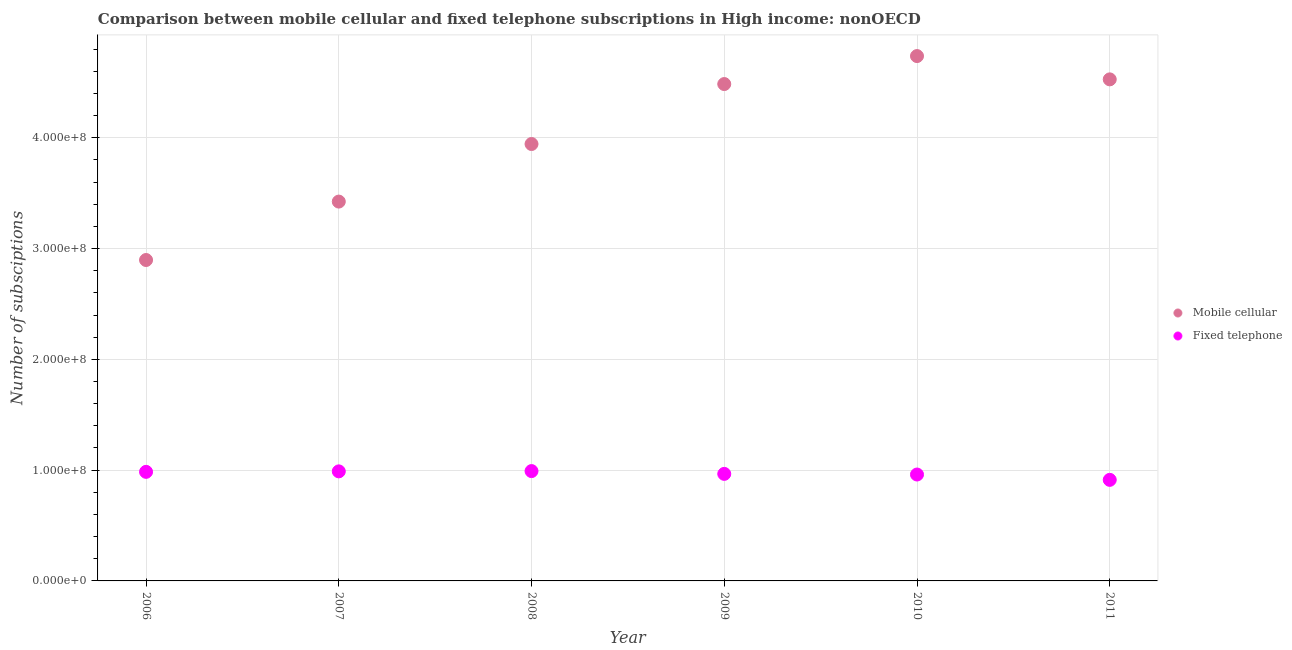How many different coloured dotlines are there?
Your answer should be compact. 2. Is the number of dotlines equal to the number of legend labels?
Keep it short and to the point. Yes. What is the number of fixed telephone subscriptions in 2009?
Your response must be concise. 9.66e+07. Across all years, what is the maximum number of fixed telephone subscriptions?
Ensure brevity in your answer.  9.91e+07. Across all years, what is the minimum number of fixed telephone subscriptions?
Make the answer very short. 9.12e+07. In which year was the number of fixed telephone subscriptions minimum?
Your answer should be very brief. 2011. What is the total number of mobile cellular subscriptions in the graph?
Your response must be concise. 2.40e+09. What is the difference between the number of mobile cellular subscriptions in 2007 and that in 2008?
Provide a short and direct response. -5.20e+07. What is the difference between the number of mobile cellular subscriptions in 2011 and the number of fixed telephone subscriptions in 2007?
Your answer should be compact. 3.54e+08. What is the average number of fixed telephone subscriptions per year?
Keep it short and to the point. 9.67e+07. In the year 2009, what is the difference between the number of fixed telephone subscriptions and number of mobile cellular subscriptions?
Keep it short and to the point. -3.52e+08. In how many years, is the number of fixed telephone subscriptions greater than 160000000?
Provide a succinct answer. 0. What is the ratio of the number of fixed telephone subscriptions in 2009 to that in 2010?
Your answer should be compact. 1.01. Is the number of mobile cellular subscriptions in 2007 less than that in 2008?
Your answer should be compact. Yes. Is the difference between the number of fixed telephone subscriptions in 2009 and 2011 greater than the difference between the number of mobile cellular subscriptions in 2009 and 2011?
Your answer should be very brief. Yes. What is the difference between the highest and the second highest number of mobile cellular subscriptions?
Give a very brief answer. 2.10e+07. What is the difference between the highest and the lowest number of mobile cellular subscriptions?
Make the answer very short. 1.84e+08. Is the sum of the number of fixed telephone subscriptions in 2008 and 2011 greater than the maximum number of mobile cellular subscriptions across all years?
Ensure brevity in your answer.  No. Does the number of mobile cellular subscriptions monotonically increase over the years?
Keep it short and to the point. No. Is the number of fixed telephone subscriptions strictly greater than the number of mobile cellular subscriptions over the years?
Your answer should be very brief. No. Are the values on the major ticks of Y-axis written in scientific E-notation?
Provide a succinct answer. Yes. Does the graph contain grids?
Offer a very short reply. Yes. Where does the legend appear in the graph?
Provide a succinct answer. Center right. How many legend labels are there?
Ensure brevity in your answer.  2. What is the title of the graph?
Your answer should be compact. Comparison between mobile cellular and fixed telephone subscriptions in High income: nonOECD. What is the label or title of the Y-axis?
Give a very brief answer. Number of subsciptions. What is the Number of subsciptions of Mobile cellular in 2006?
Your answer should be compact. 2.90e+08. What is the Number of subsciptions of Fixed telephone in 2006?
Your answer should be very brief. 9.84e+07. What is the Number of subsciptions in Mobile cellular in 2007?
Keep it short and to the point. 3.42e+08. What is the Number of subsciptions of Fixed telephone in 2007?
Offer a terse response. 9.89e+07. What is the Number of subsciptions of Mobile cellular in 2008?
Offer a terse response. 3.94e+08. What is the Number of subsciptions of Fixed telephone in 2008?
Provide a succinct answer. 9.91e+07. What is the Number of subsciptions of Mobile cellular in 2009?
Your answer should be very brief. 4.48e+08. What is the Number of subsciptions in Fixed telephone in 2009?
Offer a terse response. 9.66e+07. What is the Number of subsciptions in Mobile cellular in 2010?
Provide a short and direct response. 4.74e+08. What is the Number of subsciptions of Fixed telephone in 2010?
Offer a terse response. 9.60e+07. What is the Number of subsciptions of Mobile cellular in 2011?
Provide a succinct answer. 4.53e+08. What is the Number of subsciptions in Fixed telephone in 2011?
Give a very brief answer. 9.12e+07. Across all years, what is the maximum Number of subsciptions in Mobile cellular?
Offer a very short reply. 4.74e+08. Across all years, what is the maximum Number of subsciptions in Fixed telephone?
Offer a very short reply. 9.91e+07. Across all years, what is the minimum Number of subsciptions in Mobile cellular?
Ensure brevity in your answer.  2.90e+08. Across all years, what is the minimum Number of subsciptions of Fixed telephone?
Offer a very short reply. 9.12e+07. What is the total Number of subsciptions in Mobile cellular in the graph?
Ensure brevity in your answer.  2.40e+09. What is the total Number of subsciptions of Fixed telephone in the graph?
Keep it short and to the point. 5.80e+08. What is the difference between the Number of subsciptions of Mobile cellular in 2006 and that in 2007?
Give a very brief answer. -5.27e+07. What is the difference between the Number of subsciptions of Fixed telephone in 2006 and that in 2007?
Give a very brief answer. -4.41e+05. What is the difference between the Number of subsciptions in Mobile cellular in 2006 and that in 2008?
Your response must be concise. -1.05e+08. What is the difference between the Number of subsciptions in Fixed telephone in 2006 and that in 2008?
Provide a short and direct response. -6.91e+05. What is the difference between the Number of subsciptions of Mobile cellular in 2006 and that in 2009?
Keep it short and to the point. -1.59e+08. What is the difference between the Number of subsciptions of Fixed telephone in 2006 and that in 2009?
Provide a short and direct response. 1.83e+06. What is the difference between the Number of subsciptions in Mobile cellular in 2006 and that in 2010?
Provide a short and direct response. -1.84e+08. What is the difference between the Number of subsciptions in Fixed telephone in 2006 and that in 2010?
Your answer should be compact. 2.41e+06. What is the difference between the Number of subsciptions in Mobile cellular in 2006 and that in 2011?
Offer a terse response. -1.63e+08. What is the difference between the Number of subsciptions in Fixed telephone in 2006 and that in 2011?
Provide a short and direct response. 7.23e+06. What is the difference between the Number of subsciptions of Mobile cellular in 2007 and that in 2008?
Offer a very short reply. -5.20e+07. What is the difference between the Number of subsciptions of Fixed telephone in 2007 and that in 2008?
Keep it short and to the point. -2.50e+05. What is the difference between the Number of subsciptions of Mobile cellular in 2007 and that in 2009?
Provide a succinct answer. -1.06e+08. What is the difference between the Number of subsciptions in Fixed telephone in 2007 and that in 2009?
Offer a terse response. 2.27e+06. What is the difference between the Number of subsciptions in Mobile cellular in 2007 and that in 2010?
Ensure brevity in your answer.  -1.31e+08. What is the difference between the Number of subsciptions in Fixed telephone in 2007 and that in 2010?
Provide a succinct answer. 2.85e+06. What is the difference between the Number of subsciptions of Mobile cellular in 2007 and that in 2011?
Keep it short and to the point. -1.10e+08. What is the difference between the Number of subsciptions of Fixed telephone in 2007 and that in 2011?
Provide a succinct answer. 7.67e+06. What is the difference between the Number of subsciptions of Mobile cellular in 2008 and that in 2009?
Provide a short and direct response. -5.41e+07. What is the difference between the Number of subsciptions of Fixed telephone in 2008 and that in 2009?
Your answer should be very brief. 2.52e+06. What is the difference between the Number of subsciptions in Mobile cellular in 2008 and that in 2010?
Your response must be concise. -7.94e+07. What is the difference between the Number of subsciptions of Fixed telephone in 2008 and that in 2010?
Keep it short and to the point. 3.10e+06. What is the difference between the Number of subsciptions in Mobile cellular in 2008 and that in 2011?
Give a very brief answer. -5.83e+07. What is the difference between the Number of subsciptions of Fixed telephone in 2008 and that in 2011?
Your response must be concise. 7.92e+06. What is the difference between the Number of subsciptions of Mobile cellular in 2009 and that in 2010?
Ensure brevity in your answer.  -2.53e+07. What is the difference between the Number of subsciptions in Fixed telephone in 2009 and that in 2010?
Ensure brevity in your answer.  5.76e+05. What is the difference between the Number of subsciptions of Mobile cellular in 2009 and that in 2011?
Your response must be concise. -4.23e+06. What is the difference between the Number of subsciptions of Fixed telephone in 2009 and that in 2011?
Your response must be concise. 5.40e+06. What is the difference between the Number of subsciptions in Mobile cellular in 2010 and that in 2011?
Give a very brief answer. 2.10e+07. What is the difference between the Number of subsciptions of Fixed telephone in 2010 and that in 2011?
Ensure brevity in your answer.  4.82e+06. What is the difference between the Number of subsciptions of Mobile cellular in 2006 and the Number of subsciptions of Fixed telephone in 2007?
Give a very brief answer. 1.91e+08. What is the difference between the Number of subsciptions in Mobile cellular in 2006 and the Number of subsciptions in Fixed telephone in 2008?
Offer a very short reply. 1.91e+08. What is the difference between the Number of subsciptions in Mobile cellular in 2006 and the Number of subsciptions in Fixed telephone in 2009?
Offer a very short reply. 1.93e+08. What is the difference between the Number of subsciptions in Mobile cellular in 2006 and the Number of subsciptions in Fixed telephone in 2010?
Make the answer very short. 1.94e+08. What is the difference between the Number of subsciptions in Mobile cellular in 2006 and the Number of subsciptions in Fixed telephone in 2011?
Give a very brief answer. 1.98e+08. What is the difference between the Number of subsciptions in Mobile cellular in 2007 and the Number of subsciptions in Fixed telephone in 2008?
Provide a succinct answer. 2.43e+08. What is the difference between the Number of subsciptions in Mobile cellular in 2007 and the Number of subsciptions in Fixed telephone in 2009?
Give a very brief answer. 2.46e+08. What is the difference between the Number of subsciptions of Mobile cellular in 2007 and the Number of subsciptions of Fixed telephone in 2010?
Your response must be concise. 2.46e+08. What is the difference between the Number of subsciptions of Mobile cellular in 2007 and the Number of subsciptions of Fixed telephone in 2011?
Your answer should be very brief. 2.51e+08. What is the difference between the Number of subsciptions in Mobile cellular in 2008 and the Number of subsciptions in Fixed telephone in 2009?
Your response must be concise. 2.98e+08. What is the difference between the Number of subsciptions in Mobile cellular in 2008 and the Number of subsciptions in Fixed telephone in 2010?
Your response must be concise. 2.98e+08. What is the difference between the Number of subsciptions of Mobile cellular in 2008 and the Number of subsciptions of Fixed telephone in 2011?
Ensure brevity in your answer.  3.03e+08. What is the difference between the Number of subsciptions of Mobile cellular in 2009 and the Number of subsciptions of Fixed telephone in 2010?
Provide a succinct answer. 3.52e+08. What is the difference between the Number of subsciptions in Mobile cellular in 2009 and the Number of subsciptions in Fixed telephone in 2011?
Offer a very short reply. 3.57e+08. What is the difference between the Number of subsciptions in Mobile cellular in 2010 and the Number of subsciptions in Fixed telephone in 2011?
Provide a short and direct response. 3.82e+08. What is the average Number of subsciptions in Mobile cellular per year?
Give a very brief answer. 4.00e+08. What is the average Number of subsciptions of Fixed telephone per year?
Offer a very short reply. 9.67e+07. In the year 2006, what is the difference between the Number of subsciptions of Mobile cellular and Number of subsciptions of Fixed telephone?
Your answer should be very brief. 1.91e+08. In the year 2007, what is the difference between the Number of subsciptions of Mobile cellular and Number of subsciptions of Fixed telephone?
Your answer should be very brief. 2.43e+08. In the year 2008, what is the difference between the Number of subsciptions in Mobile cellular and Number of subsciptions in Fixed telephone?
Ensure brevity in your answer.  2.95e+08. In the year 2009, what is the difference between the Number of subsciptions in Mobile cellular and Number of subsciptions in Fixed telephone?
Give a very brief answer. 3.52e+08. In the year 2010, what is the difference between the Number of subsciptions of Mobile cellular and Number of subsciptions of Fixed telephone?
Your answer should be very brief. 3.78e+08. In the year 2011, what is the difference between the Number of subsciptions of Mobile cellular and Number of subsciptions of Fixed telephone?
Your answer should be compact. 3.61e+08. What is the ratio of the Number of subsciptions of Mobile cellular in 2006 to that in 2007?
Give a very brief answer. 0.85. What is the ratio of the Number of subsciptions in Mobile cellular in 2006 to that in 2008?
Your answer should be compact. 0.73. What is the ratio of the Number of subsciptions in Fixed telephone in 2006 to that in 2008?
Your answer should be very brief. 0.99. What is the ratio of the Number of subsciptions in Mobile cellular in 2006 to that in 2009?
Offer a very short reply. 0.65. What is the ratio of the Number of subsciptions in Fixed telephone in 2006 to that in 2009?
Ensure brevity in your answer.  1.02. What is the ratio of the Number of subsciptions in Mobile cellular in 2006 to that in 2010?
Your answer should be very brief. 0.61. What is the ratio of the Number of subsciptions of Fixed telephone in 2006 to that in 2010?
Ensure brevity in your answer.  1.03. What is the ratio of the Number of subsciptions of Mobile cellular in 2006 to that in 2011?
Your answer should be compact. 0.64. What is the ratio of the Number of subsciptions of Fixed telephone in 2006 to that in 2011?
Make the answer very short. 1.08. What is the ratio of the Number of subsciptions of Mobile cellular in 2007 to that in 2008?
Give a very brief answer. 0.87. What is the ratio of the Number of subsciptions of Fixed telephone in 2007 to that in 2008?
Your answer should be very brief. 1. What is the ratio of the Number of subsciptions of Mobile cellular in 2007 to that in 2009?
Provide a short and direct response. 0.76. What is the ratio of the Number of subsciptions in Fixed telephone in 2007 to that in 2009?
Your answer should be compact. 1.02. What is the ratio of the Number of subsciptions in Mobile cellular in 2007 to that in 2010?
Keep it short and to the point. 0.72. What is the ratio of the Number of subsciptions of Fixed telephone in 2007 to that in 2010?
Offer a terse response. 1.03. What is the ratio of the Number of subsciptions of Mobile cellular in 2007 to that in 2011?
Make the answer very short. 0.76. What is the ratio of the Number of subsciptions of Fixed telephone in 2007 to that in 2011?
Your answer should be compact. 1.08. What is the ratio of the Number of subsciptions of Mobile cellular in 2008 to that in 2009?
Keep it short and to the point. 0.88. What is the ratio of the Number of subsciptions of Fixed telephone in 2008 to that in 2009?
Keep it short and to the point. 1.03. What is the ratio of the Number of subsciptions of Mobile cellular in 2008 to that in 2010?
Make the answer very short. 0.83. What is the ratio of the Number of subsciptions of Fixed telephone in 2008 to that in 2010?
Make the answer very short. 1.03. What is the ratio of the Number of subsciptions of Mobile cellular in 2008 to that in 2011?
Your answer should be very brief. 0.87. What is the ratio of the Number of subsciptions of Fixed telephone in 2008 to that in 2011?
Offer a very short reply. 1.09. What is the ratio of the Number of subsciptions in Mobile cellular in 2009 to that in 2010?
Your response must be concise. 0.95. What is the ratio of the Number of subsciptions of Mobile cellular in 2009 to that in 2011?
Your response must be concise. 0.99. What is the ratio of the Number of subsciptions of Fixed telephone in 2009 to that in 2011?
Provide a short and direct response. 1.06. What is the ratio of the Number of subsciptions in Mobile cellular in 2010 to that in 2011?
Keep it short and to the point. 1.05. What is the ratio of the Number of subsciptions in Fixed telephone in 2010 to that in 2011?
Provide a short and direct response. 1.05. What is the difference between the highest and the second highest Number of subsciptions of Mobile cellular?
Provide a succinct answer. 2.10e+07. What is the difference between the highest and the second highest Number of subsciptions in Fixed telephone?
Make the answer very short. 2.50e+05. What is the difference between the highest and the lowest Number of subsciptions in Mobile cellular?
Your response must be concise. 1.84e+08. What is the difference between the highest and the lowest Number of subsciptions of Fixed telephone?
Give a very brief answer. 7.92e+06. 